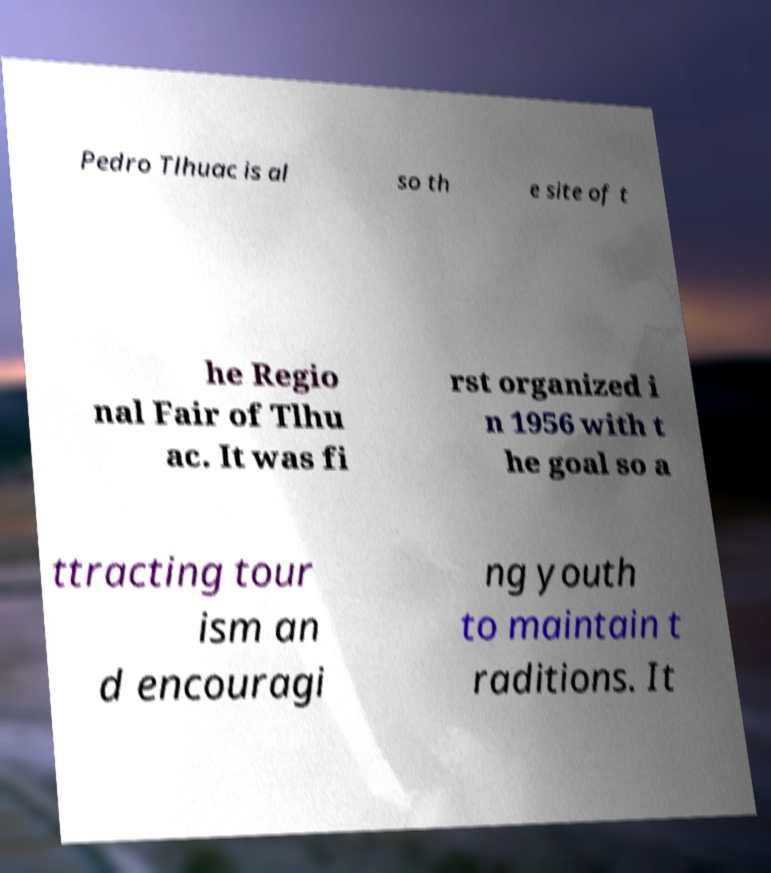Can you read and provide the text displayed in the image?This photo seems to have some interesting text. Can you extract and type it out for me? Pedro Tlhuac is al so th e site of t he Regio nal Fair of Tlhu ac. It was fi rst organized i n 1956 with t he goal so a ttracting tour ism an d encouragi ng youth to maintain t raditions. It 